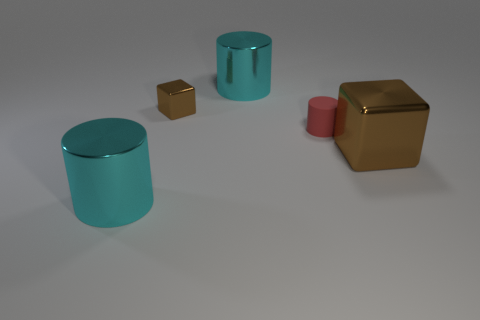Subtract all big cylinders. How many cylinders are left? 1 Add 1 tiny blue metallic objects. How many objects exist? 6 Subtract all cylinders. How many objects are left? 2 Subtract all large cyan shiny objects. Subtract all large objects. How many objects are left? 0 Add 5 cyan cylinders. How many cyan cylinders are left? 7 Add 3 matte cylinders. How many matte cylinders exist? 4 Subtract 1 red cylinders. How many objects are left? 4 